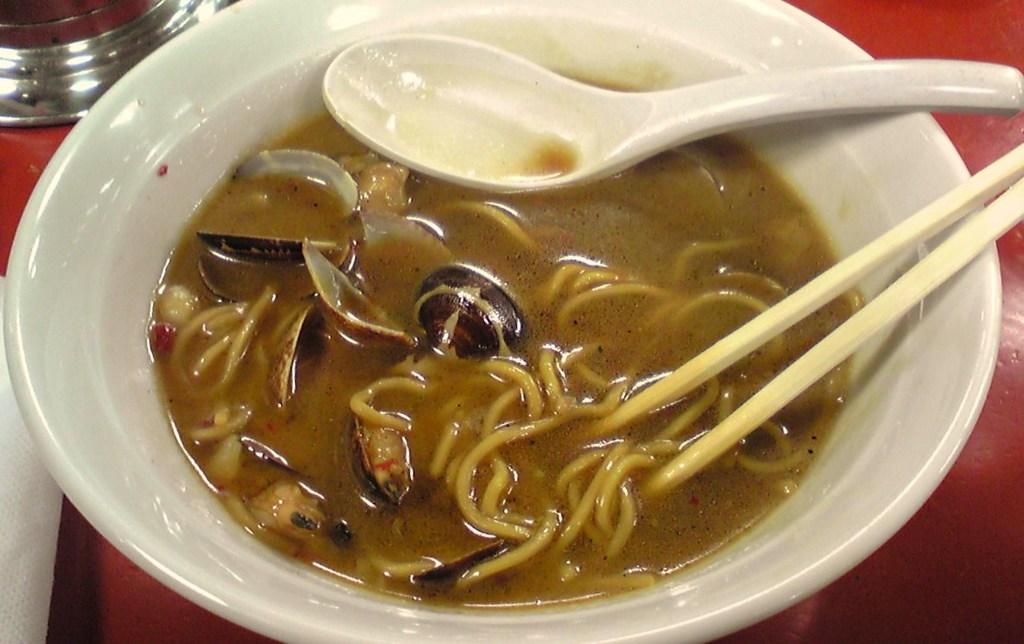What is in the bowl that is visible in the image? There is a bowl in the image, and it contains soup. What type of soup is in the bowl? The soup has noodles and vegetables in it. What utensils are present in the bowl? There is a spoon and two chopsticks in the bowl. How does the iron help in the preparation of the soup in the image? There is no iron present in the image, and it is not involved in the preparation or consumption of the soup. 